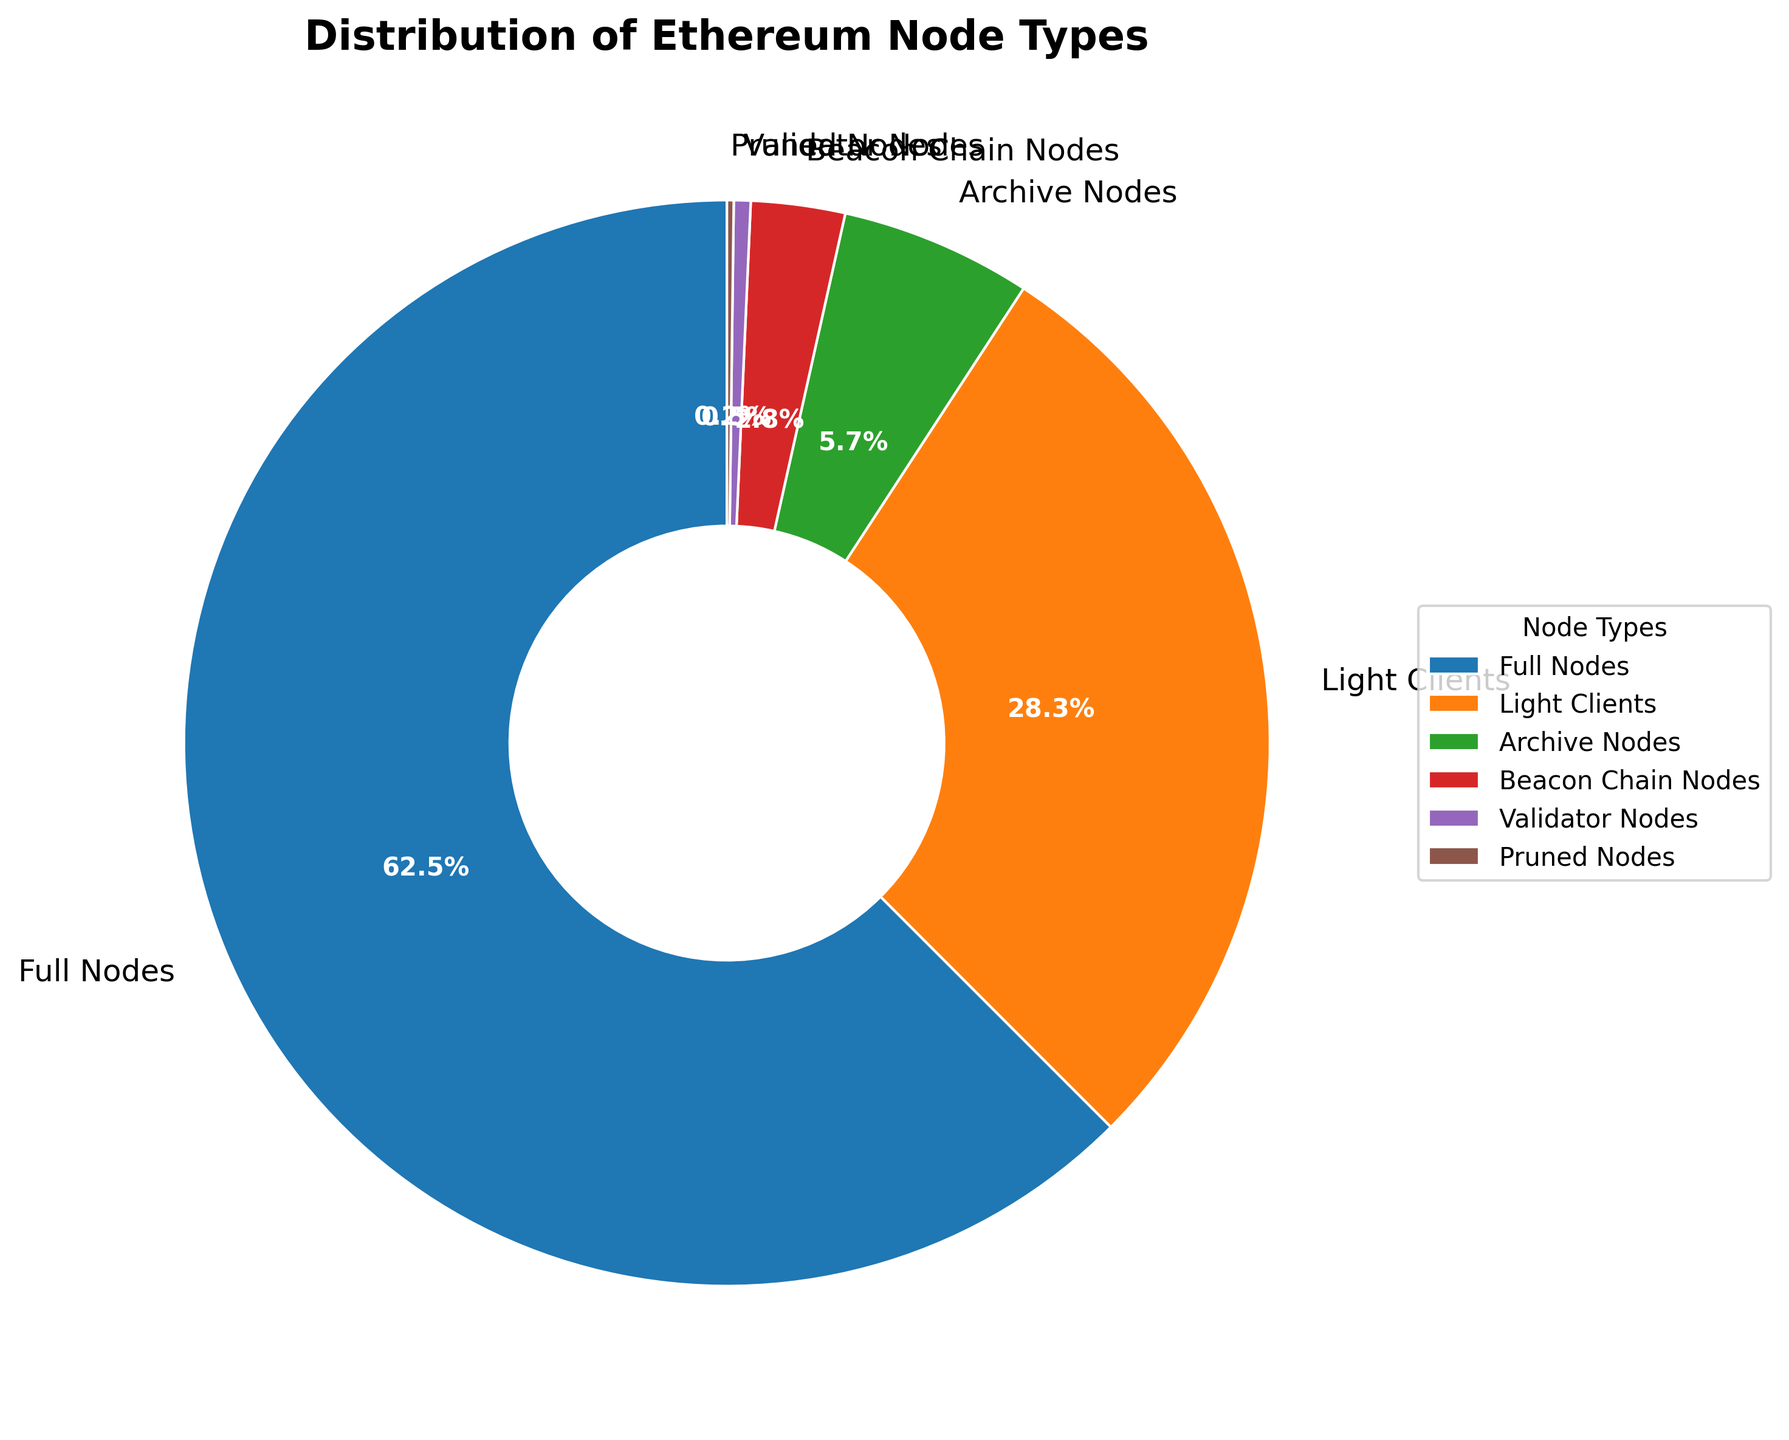What's the most common Ethereum node type? The pie chart segments show the proportions of each Ethereum node type. By looking at the largest segment, we can identify the most common node type. The largest segment represents Full Nodes with 62.5%.
Answer: Full Nodes Which node types comprise more than a quarter of the total nodes? The segments can be compared to identify those with proportions greater than 25%. The Full Nodes segment at 62.5% and Light Clients at 28.3% are the only ones exceeding this threshold.
Answer: Full Nodes, Light Clients How much larger is the proportion of Full Nodes compared to Light Clients? To find the difference in proportions, subtract the percentage of Light Clients from that of Full Nodes: 62.5% - 28.3% = 34.2%.
Answer: 34.2% Which node type has the smallest representation? By examining the smallest segment in the pie chart, we see that Pruned Nodes, with a proportion of 0.2%, have the smallest representation.
Answer: Pruned Nodes What is the combined percentage of Beacon Chain Nodes and Validator Nodes? Sum the percentages of Beacon Chain Nodes and Validator Nodes: 2.8% + 0.5% = 3.3%.
Answer: 3.3% Are there more Light Clients than all the specialized nodes (Archive Nodes, Beacon Chain Nodes, Validator Nodes, Pruned Nodes) combined? Sum the percentages of the specialized nodes: 5.7% (Archive Nodes) + 2.8% (Beacon Chain Nodes) + 0.5% (Validator Nodes) + 0.2% (Pruned Nodes) = 9.2%. Since 28.3% (Light Clients) > 9.2%, there are more Light Clients.
Answer: Yes Which node types are represented by the darkest and lightest colors? The pie chart uses different colors for the node types. Full Nodes, with the largest slice, appear in a darker blue, while Pruned Nodes, the smallest slice, appear in perhaps a brownish color, which looks lighter.
Answer: Full Nodes (dark), Pruned Nodes (light) What percentage of the pie chart does not consist of Full Nodes? Subtract the percentage of Full Nodes from 100%: 100% - 62.5% = 37.5%.
Answer: 37.5% 